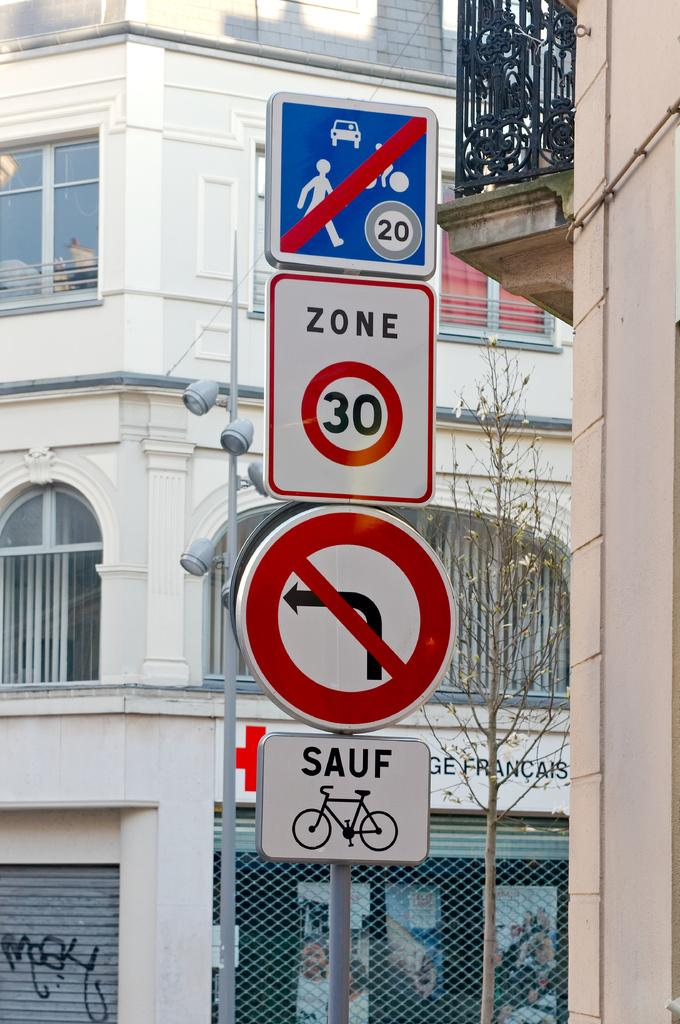<image>
Relay a brief, clear account of the picture shown. The speed limit in the city is 30 